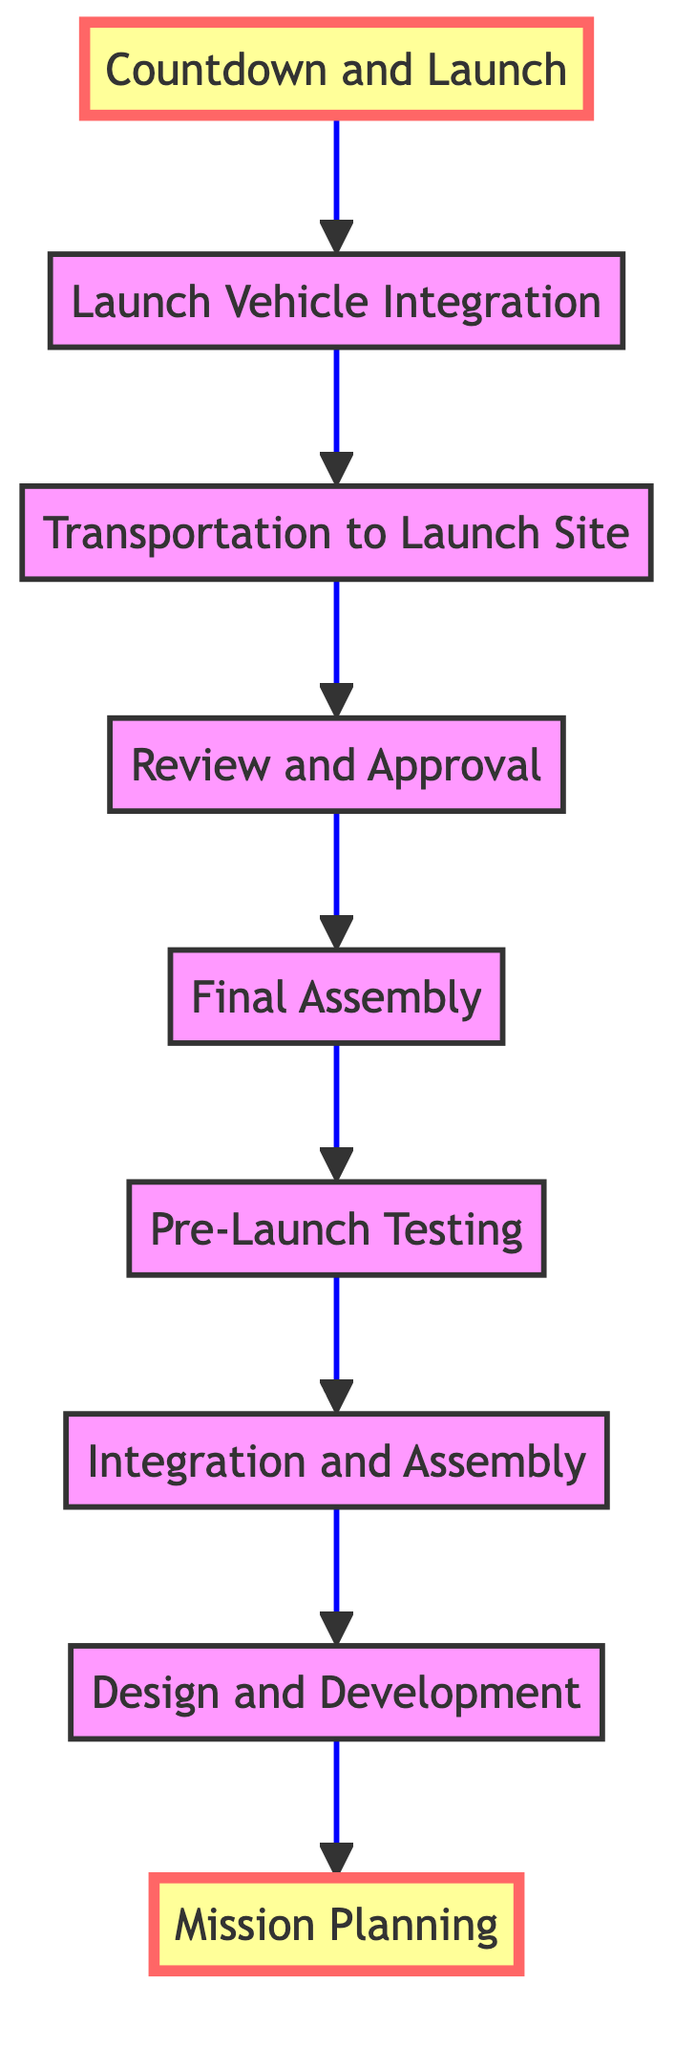What is the first step in preparing a spacecraft for launch? The diagram shows that "Mission Planning" is the first element in the flow, meaning it is the initial step.
Answer: Mission Planning How many steps are involved in the process of preparing a spacecraft for launch? By counting the elements listed in the diagram, we see that there are 9 steps in total.
Answer: 9 What follows after "Final Assembly"? Looking at the flow direction, "Final Assembly" is followed by "Review and Approval".
Answer: Review and Approval Which step comes directly before "Countdown and Launch"? Checking the connections from the diagram, "Launch Vehicle Integration" is the step that comes directly before "Countdown and Launch".
Answer: Launch Vehicle Integration What is the last step in preparing a spacecraft for launch? The final element of the flow chart indicates that the last step is "Countdown and Launch".
Answer: Countdown and Launch What are the two highlighted steps in the diagram? The highlighted steps in the diagram, indicated by different formatting, are "Mission Planning" and "Countdown and Launch".
Answer: Mission Planning and Countdown and Launch Which two steps share a direct connection in the process? The flow from "Integration and Assembly" leads directly to "Pre-Launch Testing", showing they are directly connected.
Answer: Integration and Assembly and Pre-Launch Testing What is the purpose of "Pre-Launch Testing"? The description for "Pre-Launch Testing" indicates it involves conducting functional tests, environmental tests, and simulations to ensure operational integrity.
Answer: Conduct functional tests, environmental tests, and simulations What is the main activity during "Transportation to Launch Site"? The diagram states that this step involves transporting the spacecraft to the launch site and completing pre-launch preparations.
Answer: Transport the spacecraft to the launch site and complete pre-launch preparations 